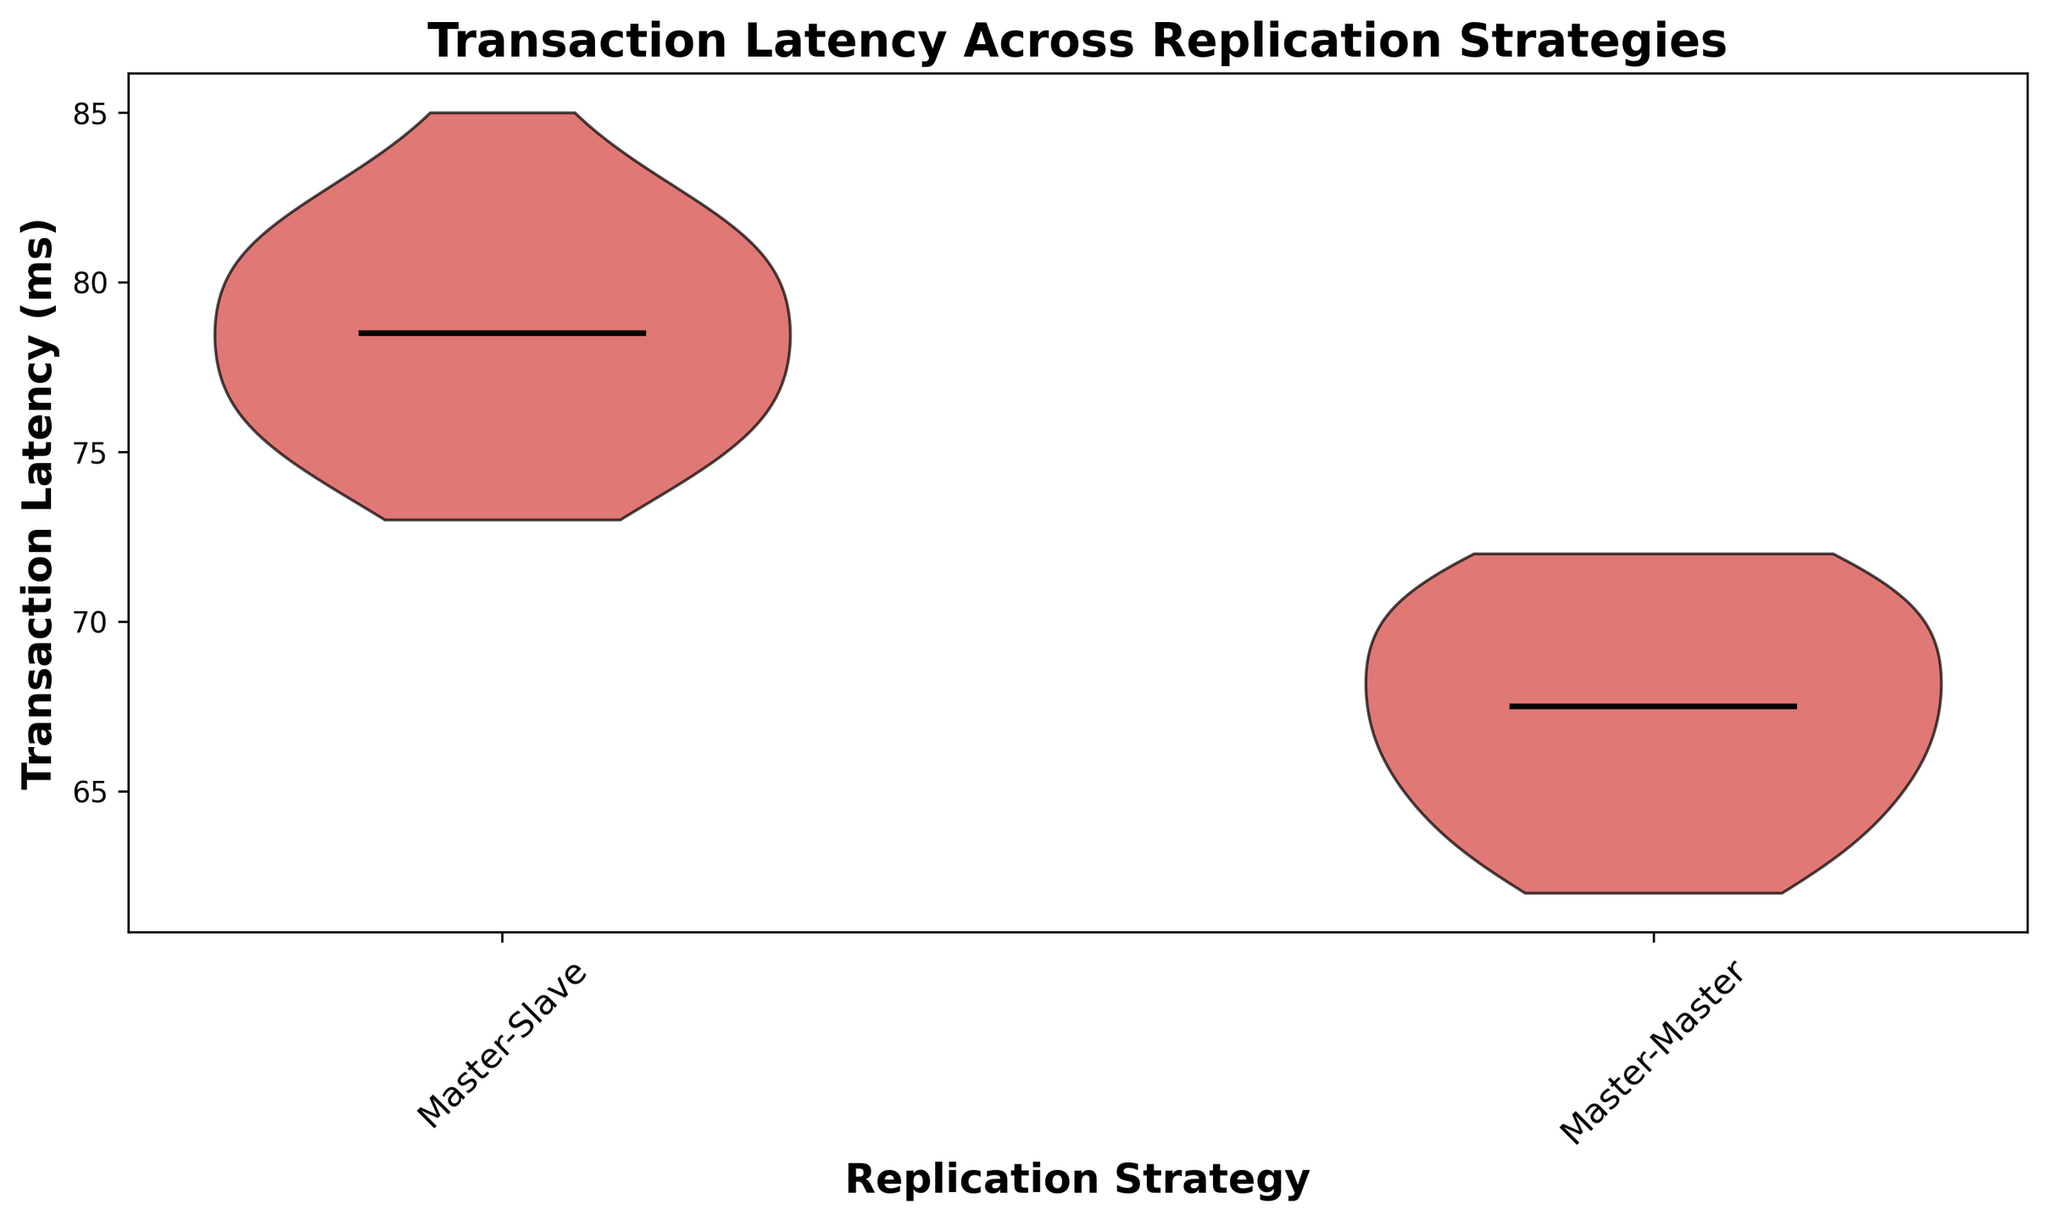What are the median transaction latencies for Master-Slave and Master-Master replication strategies? To find the median transaction latencies for each strategy, locate the horizontal lines inside the individual violins on the violin plot. For Master-Slave, the line is around 78 ms, while for Master-Master, it's around 67 ms.
Answer: Master-Slave: 78 ms, Master-Master: 67 ms Which replication strategy shows a lower overall transaction latency? Compare the positions of the violins on the y-axis. The Master-Master strategy has a lower median and overall position on the y-axis compared to Master-Slave, indicating lower overall transaction latency.
Answer: Master-Master What is the approximate range of transaction latencies for the Master-Slave replication strategy? The range is represented by the upper and lower extents of the violin. For Master-Slave, the range is approximately from 73 ms to 85 ms.
Answer: 73 ms to 85 ms Which replication strategy has a wider distribution of transaction latencies? Look at the width of the violins. The Master-Slave strategy has a wider distribution represented by its broader violin, indicating more variability in transaction latencies.
Answer: Master-Slave How does the shape of the violin for Master-Master replication strategy indicate its latency distribution? The shape is slimmer and more uniform, which suggests that the transaction latencies for Master-Master are more consistently around the central value with less variability.
Answer: Slim and uniform distribution Are there any outliers in the transaction latencies for either replication strategy? The violin plot does not show any distinct data points outside the body, indicating no significant outliers in the transaction latencies for both strategies.
Answer: No What can be inferred about the mean transaction latency from the violin plot? The mean is not explicitly shown in the plot (only medians are), but considering the symmetry around the median, the mean for both strategies should be very close to their respective medians.
Answer: Close to medians (Master-Slave: 78 ms, Master-Master: 67 ms) How do the medians of the two replication strategies compare? The median of the Master-Slave strategy is higher than that of the Master-Master strategy, indicating that transactions generally take longer in the Master-Slave setup.
Answer: Master-Slave > Master-Master Does the Master-Master replication strategy show higher consistency in transaction latencies than the Master-Slave strategy? Yes, judging by the narrower and more consistent shape of the violin for Master-Master, it indicates less variability in transaction latencies compared to the wider shape for Master-Slave.
Answer: Yes 